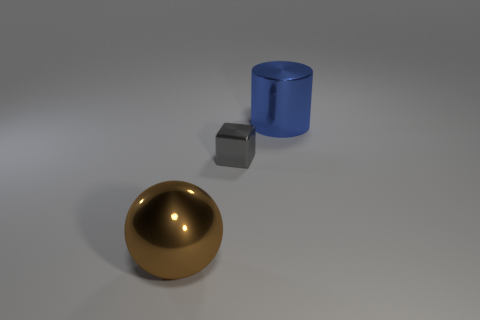Could you describe the lighting in the scene? The scene is softly lit with what seems to be a singular light source from above, casting gentle shadows on the floor to the right of the objects from the viewer's perspective. The surfaces of the objects have highlights that suggest a non-aggressive illumination in the environment. 